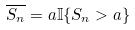<formula> <loc_0><loc_0><loc_500><loc_500>\overline { S _ { n } } = a \mathbb { I } \{ S _ { n } > a \}</formula> 